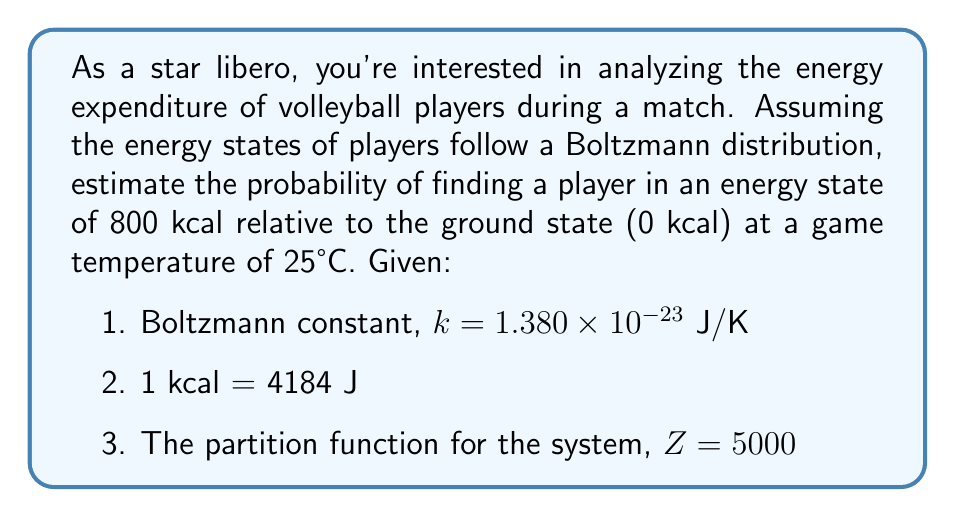Show me your answer to this math problem. To solve this problem, we'll use the Boltzmann distribution formula:

$$P(E_i) = \frac{1}{Z} e^{-E_i / (kT)}$$

Where:
$P(E_i)$ is the probability of finding a player in energy state $E_i$
$Z$ is the partition function
$E_i$ is the energy state
$k$ is the Boltzmann constant
$T$ is the temperature in Kelvin

Step 1: Convert temperature to Kelvin
$T = 25°C + 273.15 = 298.15$ K

Step 2: Convert energy from kcal to Joules
$E = 800 \text{ kcal} \times 4184 \text{ J/kcal} = 3,347,200 \text{ J}$

Step 3: Calculate $E / (kT)$
$$\frac{E}{kT} = \frac{3,347,200}{(1.380 \times 10^{-23})(298.15)} = 8.12 \times 10^{26}$$

Step 4: Calculate $e^{-E / (kT)}$
$$e^{-E / (kT)} = e^{-8.12 \times 10^{26}} \approx 0$$

Step 5: Apply the Boltzmann distribution formula
$$P(E) = \frac{1}{Z} e^{-E / (kT)} = \frac{1}{5000} \times 0 = 0$$

The probability is effectively zero due to the extremely large negative exponent.
Answer: $0$ 